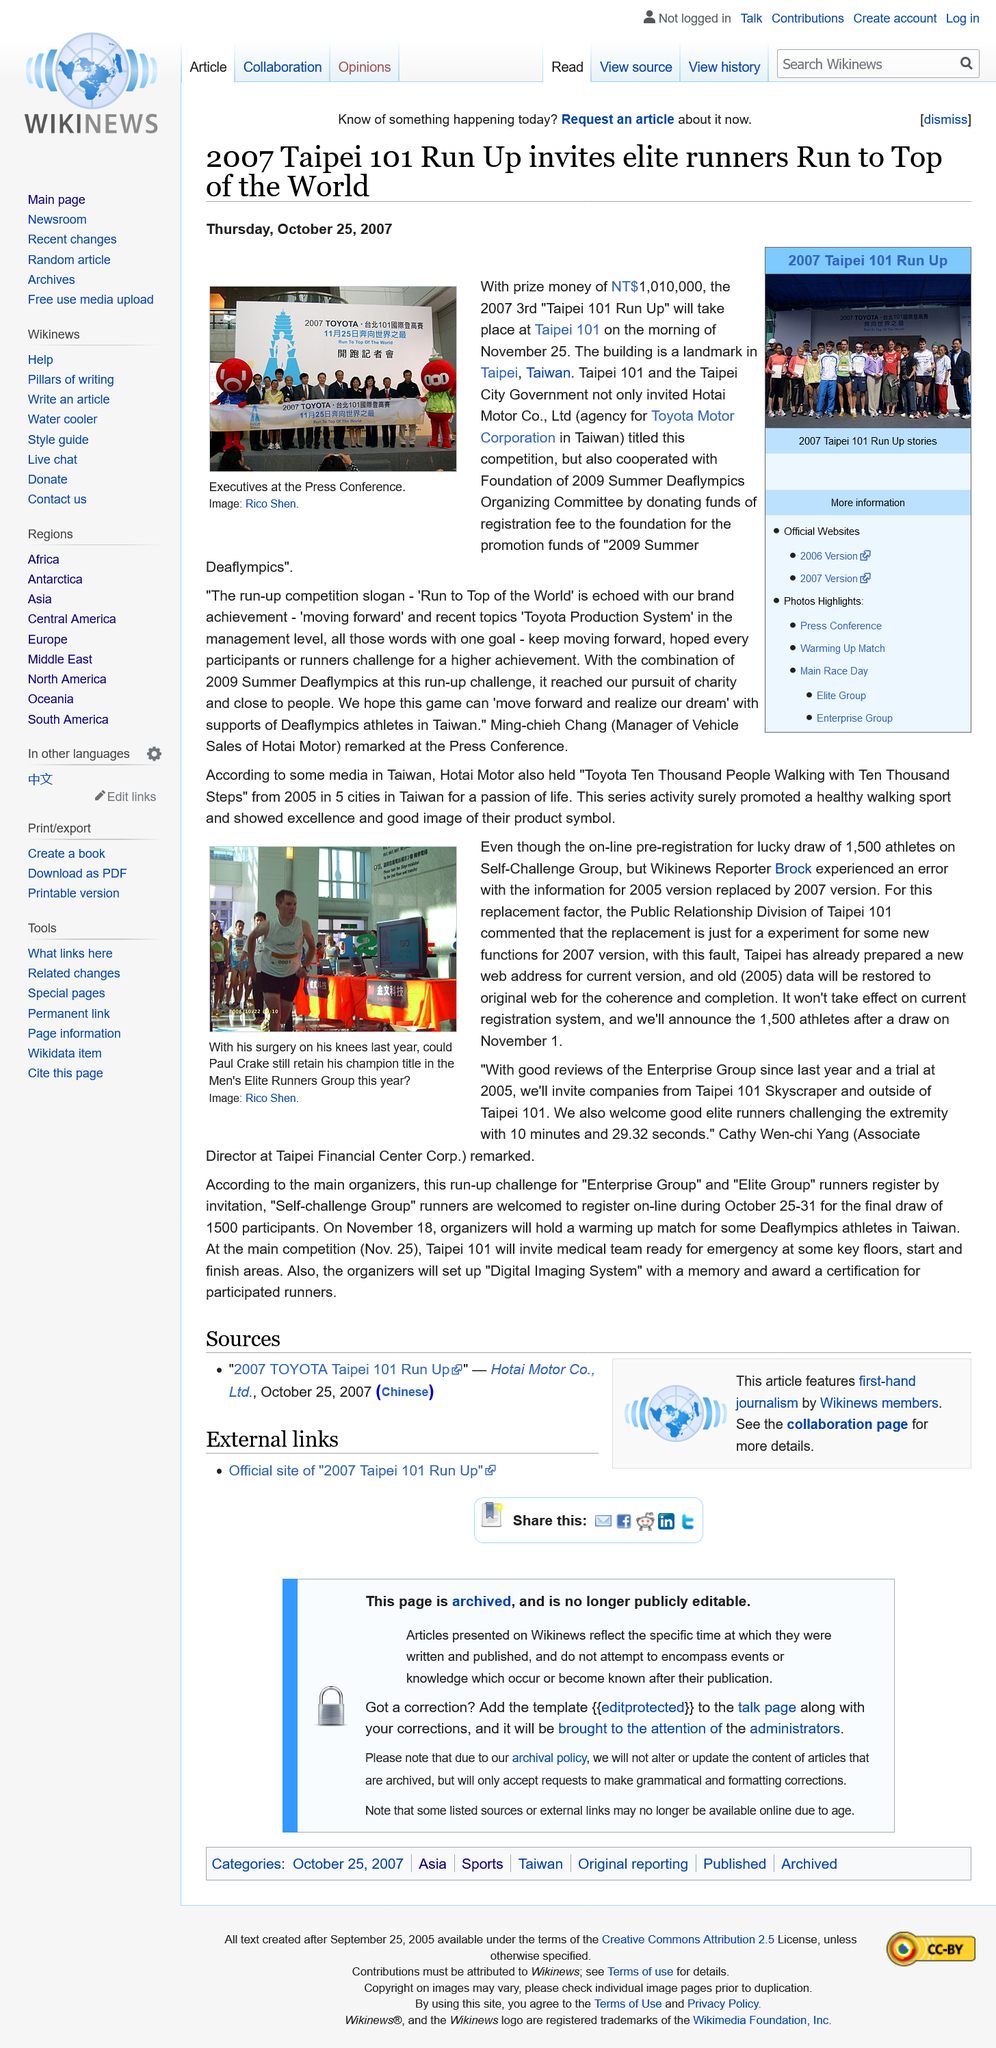Mention a couple of crucial points in this snapshot. It is estimated that 1,500 athletes will be selected in the draw for the upcoming event. The "Self-challenge Group" runners should register during the period of October 25-31. The event was sponsored by Toyota, a prominent automotive company that is connected to the event in some way. It is known that the creator of the Paul Crake image is Rico Shen. The runner's up slogan was "Run to the top of the world. 